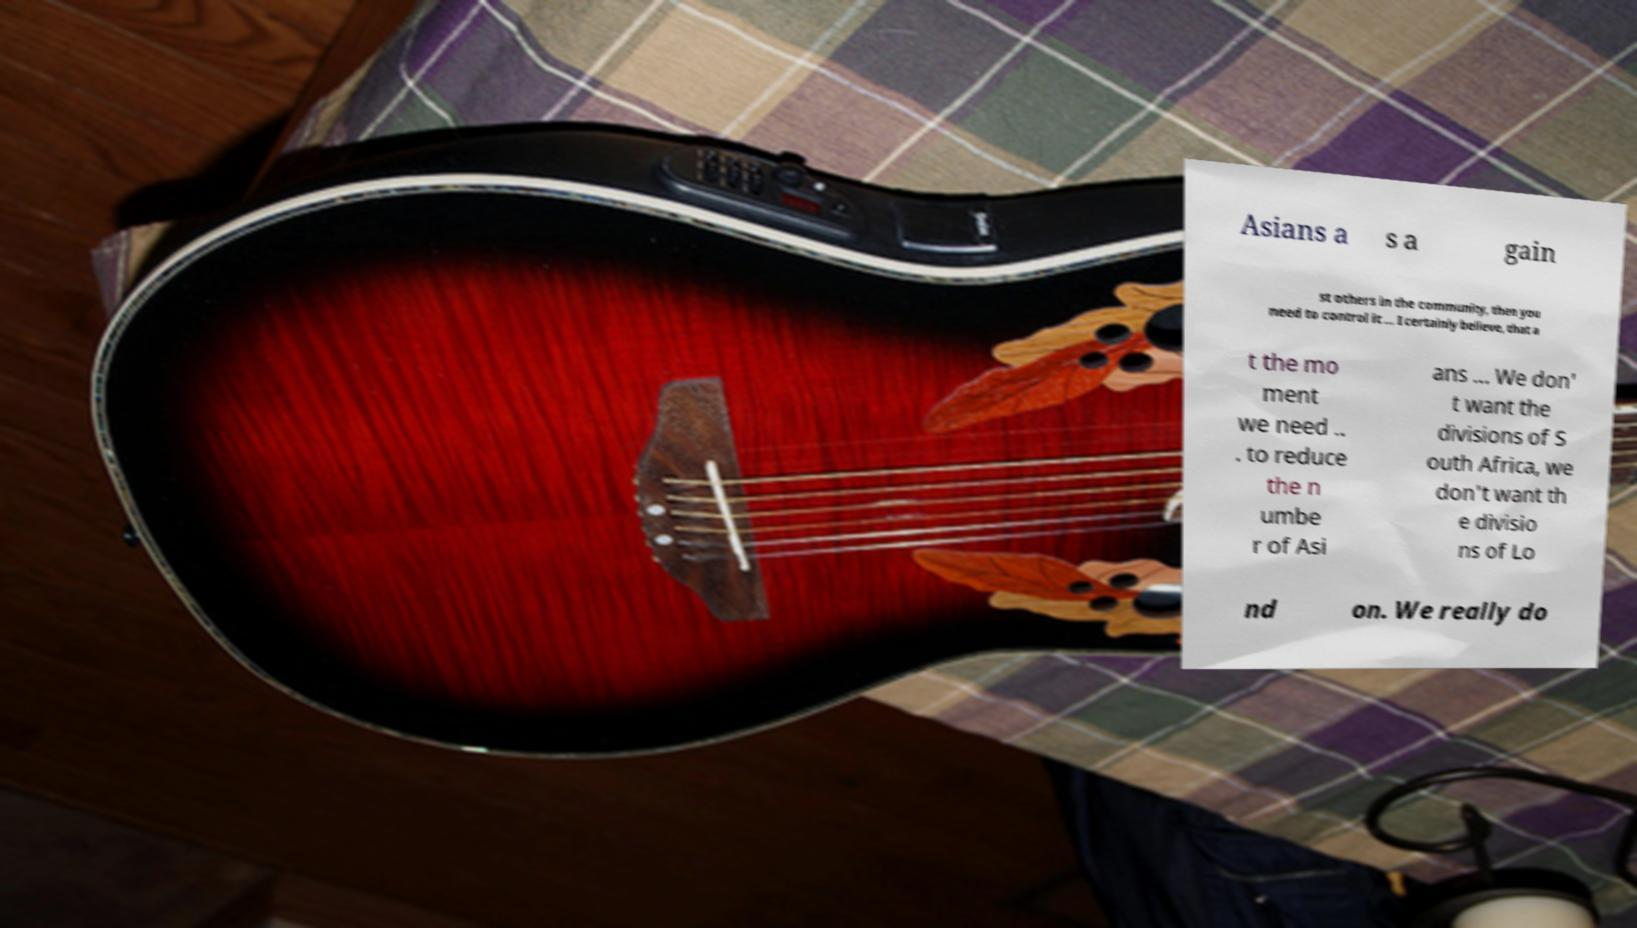Could you assist in decoding the text presented in this image and type it out clearly? Asians a s a gain st others in the community, then you need to control it ... I certainly believe, that a t the mo ment we need .. . to reduce the n umbe r of Asi ans ... We don' t want the divisions of S outh Africa, we don't want th e divisio ns of Lo nd on. We really do 